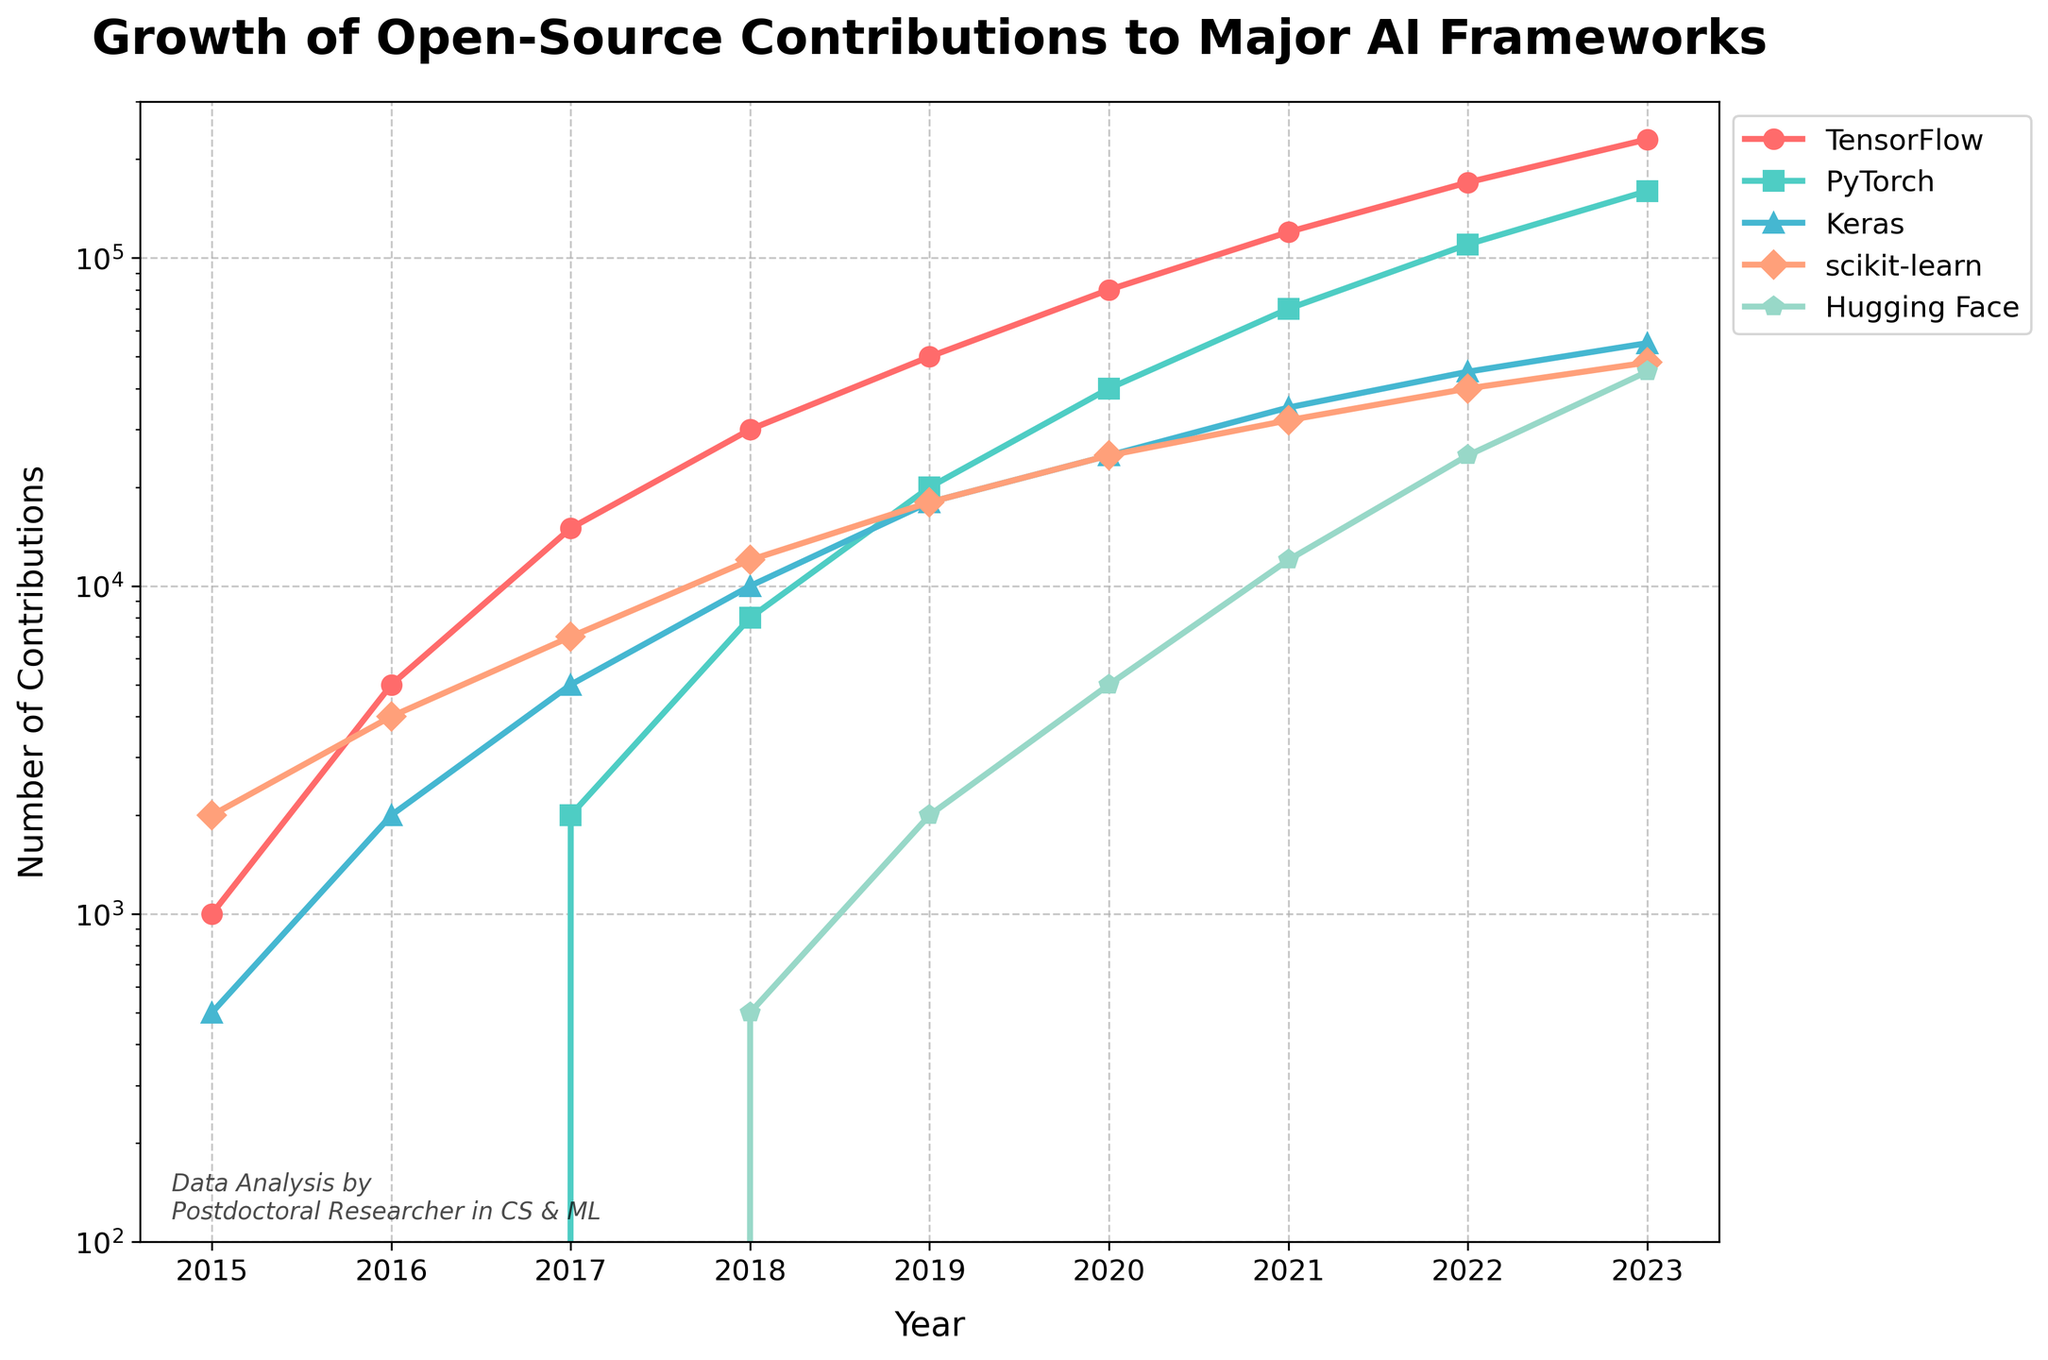Which AI framework had the greatest number of open-source contributions in 2022? By observing the y-axis values for each AI framework in 2022, TensorFlow has the highest number of contributions at 170,000.
Answer: TensorFlow How many total contributions were made to all frameworks in 2019? Sum the contributions for each framework in 2019: TensorFlow (50,000) + PyTorch (20,000) + Keras (18,000) + scikit-learn (18,000) + Hugging Face (2,000) = 108,000.
Answer: 108,000 By what factor did the contributions to PyTorch increase from 2017 to 2023? The contributions to PyTorch in 2017 were 2,000 and in 2023 were 160,000. The factor of increase is 160,000 / 2,000 = 80.
Answer: 80 Which framework exhibited the steepest growth in contributions between 2015 and 2023? By observing the general trajectory and slopes of the lines, TensorFlow shows the steepest growth with an increase from 1,000 in 2015 to 230,000 in 2023.
Answer: TensorFlow What is the average number of contributions to Keras from 2016 to 2020? The contributions to Keras from 2016 to 2020 are 2,000, 5,000, 10,000, 18,000, and 25,000. The average is (2,000 + 5,000 + 10,000 + 18,000 + 25,000) / 5 = 12,000.
Answer: 12,000 Which frameworks had zero contributions in 2015? By looking at the data points, both PyTorch and Hugging Face had zero contributions in 2015.
Answer: PyTorch and Hugging Face Was there any year where scikit-learn had the highest number of contributions among all frameworks? By examining each year from 2015 to 2023, scikit-learn never had the highest number of contributions.
Answer: No How did the number of contributions to Hugging Face in 2020 compare to Keras in 2018? In 2020, Hugging Face had 5,000 contributions and Keras had 10,000 in 2018. Therefore, Hugging Face in 2020 had 5,000 fewer contributions compared to Keras in 2018.
Answer: 5,000 fewer What was the contribution difference between the framework with the highest and lowest contributions in 2023? In 2023, TensorFlow had the highest contributions (230,000) and Keras had the lowest (55,000). The difference is 230,000 - 55,000 = 175,000.
Answer: 175,000 How does the contribution growth trend of Hugging Face between 2019 and 2023 compare to TensorFlow within the same period? From 2019 to 2023, the contributions to Hugging Face grew from 2,000 to 45,000, an increase of 43,000. TensorFlow grew from 50,000 to 230,000, an increase of 180,000. Thus, TensorFlow's growth was significantly higher.
Answer: TensorFlow's growth was higher 